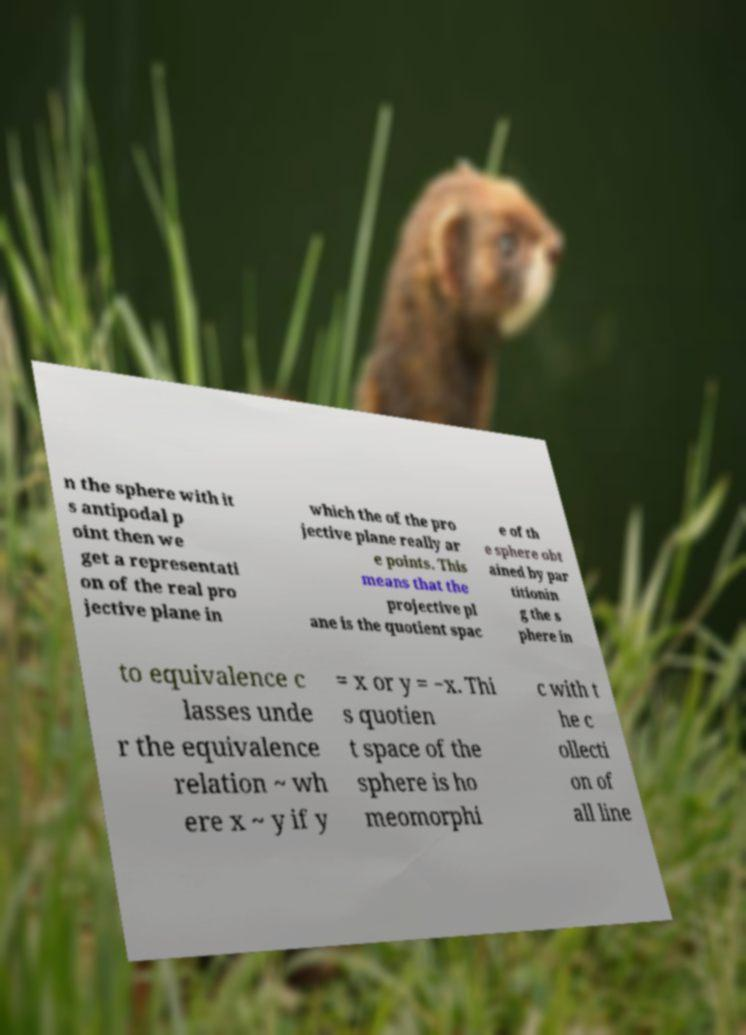Can you read and provide the text displayed in the image?This photo seems to have some interesting text. Can you extract and type it out for me? n the sphere with it s antipodal p oint then we get a representati on of the real pro jective plane in which the of the pro jective plane really ar e points. This means that the projective pl ane is the quotient spac e of th e sphere obt ained by par titionin g the s phere in to equivalence c lasses unde r the equivalence relation ~ wh ere x ~ y if y = x or y = −x. Thi s quotien t space of the sphere is ho meomorphi c with t he c ollecti on of all line 